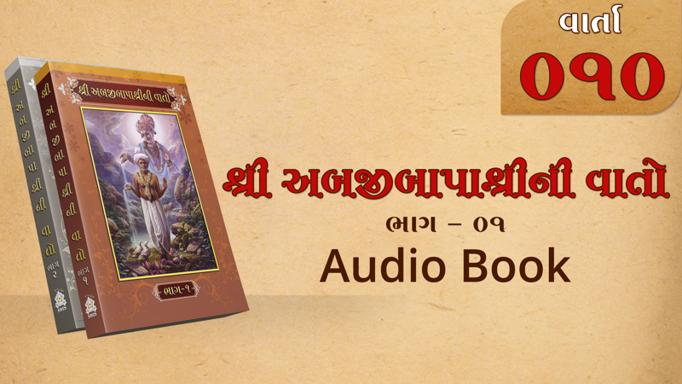What format is available for this book? The book shown in the image is available in audio format. This can be clearly seen from the text 'Audio Book' displayed beneath the book cover image. It’s a convenient option for those who prefer listening to their literature, possibly while multitasking or on the go. 